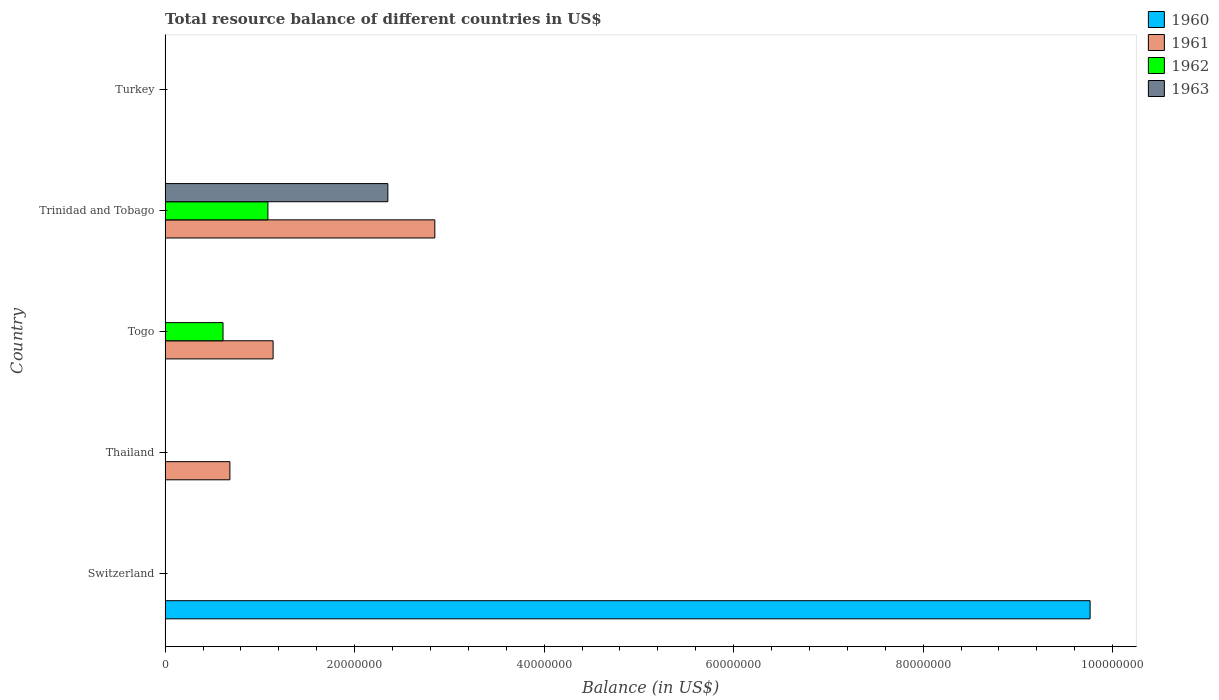How many different coloured bars are there?
Provide a succinct answer. 4. Are the number of bars per tick equal to the number of legend labels?
Offer a terse response. No. Are the number of bars on each tick of the Y-axis equal?
Your answer should be compact. No. What is the label of the 3rd group of bars from the top?
Provide a succinct answer. Togo. In how many cases, is the number of bars for a given country not equal to the number of legend labels?
Ensure brevity in your answer.  5. What is the total resource balance in 1960 in Togo?
Make the answer very short. 0. Across all countries, what is the maximum total resource balance in 1961?
Ensure brevity in your answer.  2.85e+07. In which country was the total resource balance in 1962 maximum?
Make the answer very short. Trinidad and Tobago. What is the total total resource balance in 1962 in the graph?
Offer a terse response. 1.70e+07. What is the difference between the total resource balance in 1961 in Togo and that in Trinidad and Tobago?
Offer a very short reply. -1.71e+07. What is the difference between the total resource balance in 1963 in Togo and the total resource balance in 1960 in Thailand?
Ensure brevity in your answer.  0. What is the average total resource balance in 1962 per country?
Make the answer very short. 3.39e+06. What is the difference between the total resource balance in 1963 and total resource balance in 1961 in Trinidad and Tobago?
Keep it short and to the point. -4.96e+06. What is the difference between the highest and the second highest total resource balance in 1961?
Provide a succinct answer. 1.71e+07. What is the difference between the highest and the lowest total resource balance in 1962?
Ensure brevity in your answer.  1.08e+07. In how many countries, is the total resource balance in 1962 greater than the average total resource balance in 1962 taken over all countries?
Provide a short and direct response. 2. Is it the case that in every country, the sum of the total resource balance in 1963 and total resource balance in 1960 is greater than the total resource balance in 1961?
Your response must be concise. No. How many bars are there?
Give a very brief answer. 7. Are all the bars in the graph horizontal?
Offer a terse response. Yes. What is the difference between two consecutive major ticks on the X-axis?
Ensure brevity in your answer.  2.00e+07. Are the values on the major ticks of X-axis written in scientific E-notation?
Your answer should be compact. No. Does the graph contain any zero values?
Provide a short and direct response. Yes. What is the title of the graph?
Offer a very short reply. Total resource balance of different countries in US$. What is the label or title of the X-axis?
Give a very brief answer. Balance (in US$). What is the Balance (in US$) of 1960 in Switzerland?
Give a very brief answer. 9.76e+07. What is the Balance (in US$) in 1962 in Switzerland?
Give a very brief answer. 0. What is the Balance (in US$) in 1963 in Switzerland?
Give a very brief answer. 0. What is the Balance (in US$) in 1960 in Thailand?
Offer a very short reply. 0. What is the Balance (in US$) in 1961 in Thailand?
Your answer should be compact. 6.84e+06. What is the Balance (in US$) of 1962 in Thailand?
Provide a succinct answer. 0. What is the Balance (in US$) of 1960 in Togo?
Give a very brief answer. 0. What is the Balance (in US$) in 1961 in Togo?
Your answer should be very brief. 1.14e+07. What is the Balance (in US$) of 1962 in Togo?
Offer a very short reply. 6.11e+06. What is the Balance (in US$) of 1963 in Togo?
Your answer should be compact. 0. What is the Balance (in US$) of 1961 in Trinidad and Tobago?
Ensure brevity in your answer.  2.85e+07. What is the Balance (in US$) of 1962 in Trinidad and Tobago?
Your answer should be compact. 1.08e+07. What is the Balance (in US$) in 1963 in Trinidad and Tobago?
Keep it short and to the point. 2.35e+07. What is the Balance (in US$) of 1963 in Turkey?
Give a very brief answer. 0. Across all countries, what is the maximum Balance (in US$) of 1960?
Keep it short and to the point. 9.76e+07. Across all countries, what is the maximum Balance (in US$) in 1961?
Your answer should be compact. 2.85e+07. Across all countries, what is the maximum Balance (in US$) of 1962?
Offer a terse response. 1.08e+07. Across all countries, what is the maximum Balance (in US$) in 1963?
Ensure brevity in your answer.  2.35e+07. Across all countries, what is the minimum Balance (in US$) of 1960?
Give a very brief answer. 0. Across all countries, what is the minimum Balance (in US$) of 1963?
Offer a terse response. 0. What is the total Balance (in US$) of 1960 in the graph?
Your response must be concise. 9.76e+07. What is the total Balance (in US$) of 1961 in the graph?
Ensure brevity in your answer.  4.67e+07. What is the total Balance (in US$) in 1962 in the graph?
Your answer should be compact. 1.70e+07. What is the total Balance (in US$) in 1963 in the graph?
Give a very brief answer. 2.35e+07. What is the difference between the Balance (in US$) in 1961 in Thailand and that in Togo?
Ensure brevity in your answer.  -4.56e+06. What is the difference between the Balance (in US$) of 1961 in Thailand and that in Trinidad and Tobago?
Ensure brevity in your answer.  -2.16e+07. What is the difference between the Balance (in US$) in 1961 in Togo and that in Trinidad and Tobago?
Your answer should be compact. -1.71e+07. What is the difference between the Balance (in US$) of 1962 in Togo and that in Trinidad and Tobago?
Offer a terse response. -4.74e+06. What is the difference between the Balance (in US$) in 1960 in Switzerland and the Balance (in US$) in 1961 in Thailand?
Offer a terse response. 9.08e+07. What is the difference between the Balance (in US$) of 1960 in Switzerland and the Balance (in US$) of 1961 in Togo?
Give a very brief answer. 8.62e+07. What is the difference between the Balance (in US$) of 1960 in Switzerland and the Balance (in US$) of 1962 in Togo?
Provide a short and direct response. 9.15e+07. What is the difference between the Balance (in US$) in 1960 in Switzerland and the Balance (in US$) in 1961 in Trinidad and Tobago?
Provide a succinct answer. 6.92e+07. What is the difference between the Balance (in US$) in 1960 in Switzerland and the Balance (in US$) in 1962 in Trinidad and Tobago?
Provide a succinct answer. 8.68e+07. What is the difference between the Balance (in US$) in 1960 in Switzerland and the Balance (in US$) in 1963 in Trinidad and Tobago?
Offer a terse response. 7.41e+07. What is the difference between the Balance (in US$) of 1961 in Thailand and the Balance (in US$) of 1962 in Togo?
Provide a short and direct response. 7.25e+05. What is the difference between the Balance (in US$) of 1961 in Thailand and the Balance (in US$) of 1962 in Trinidad and Tobago?
Your answer should be very brief. -4.01e+06. What is the difference between the Balance (in US$) of 1961 in Thailand and the Balance (in US$) of 1963 in Trinidad and Tobago?
Your answer should be very brief. -1.67e+07. What is the difference between the Balance (in US$) in 1961 in Togo and the Balance (in US$) in 1962 in Trinidad and Tobago?
Offer a very short reply. 5.50e+05. What is the difference between the Balance (in US$) of 1961 in Togo and the Balance (in US$) of 1963 in Trinidad and Tobago?
Provide a short and direct response. -1.21e+07. What is the difference between the Balance (in US$) of 1962 in Togo and the Balance (in US$) of 1963 in Trinidad and Tobago?
Your answer should be compact. -1.74e+07. What is the average Balance (in US$) of 1960 per country?
Keep it short and to the point. 1.95e+07. What is the average Balance (in US$) in 1961 per country?
Ensure brevity in your answer.  9.34e+06. What is the average Balance (in US$) in 1962 per country?
Ensure brevity in your answer.  3.39e+06. What is the average Balance (in US$) of 1963 per country?
Offer a very short reply. 4.70e+06. What is the difference between the Balance (in US$) in 1961 and Balance (in US$) in 1962 in Togo?
Your answer should be compact. 5.29e+06. What is the difference between the Balance (in US$) in 1961 and Balance (in US$) in 1962 in Trinidad and Tobago?
Give a very brief answer. 1.76e+07. What is the difference between the Balance (in US$) in 1961 and Balance (in US$) in 1963 in Trinidad and Tobago?
Your response must be concise. 4.96e+06. What is the difference between the Balance (in US$) of 1962 and Balance (in US$) of 1963 in Trinidad and Tobago?
Provide a succinct answer. -1.27e+07. What is the ratio of the Balance (in US$) of 1961 in Thailand to that in Togo?
Offer a very short reply. 0.6. What is the ratio of the Balance (in US$) of 1961 in Thailand to that in Trinidad and Tobago?
Offer a terse response. 0.24. What is the ratio of the Balance (in US$) of 1961 in Togo to that in Trinidad and Tobago?
Offer a very short reply. 0.4. What is the ratio of the Balance (in US$) in 1962 in Togo to that in Trinidad and Tobago?
Give a very brief answer. 0.56. What is the difference between the highest and the second highest Balance (in US$) in 1961?
Ensure brevity in your answer.  1.71e+07. What is the difference between the highest and the lowest Balance (in US$) in 1960?
Provide a succinct answer. 9.76e+07. What is the difference between the highest and the lowest Balance (in US$) of 1961?
Offer a very short reply. 2.85e+07. What is the difference between the highest and the lowest Balance (in US$) in 1962?
Give a very brief answer. 1.08e+07. What is the difference between the highest and the lowest Balance (in US$) in 1963?
Give a very brief answer. 2.35e+07. 